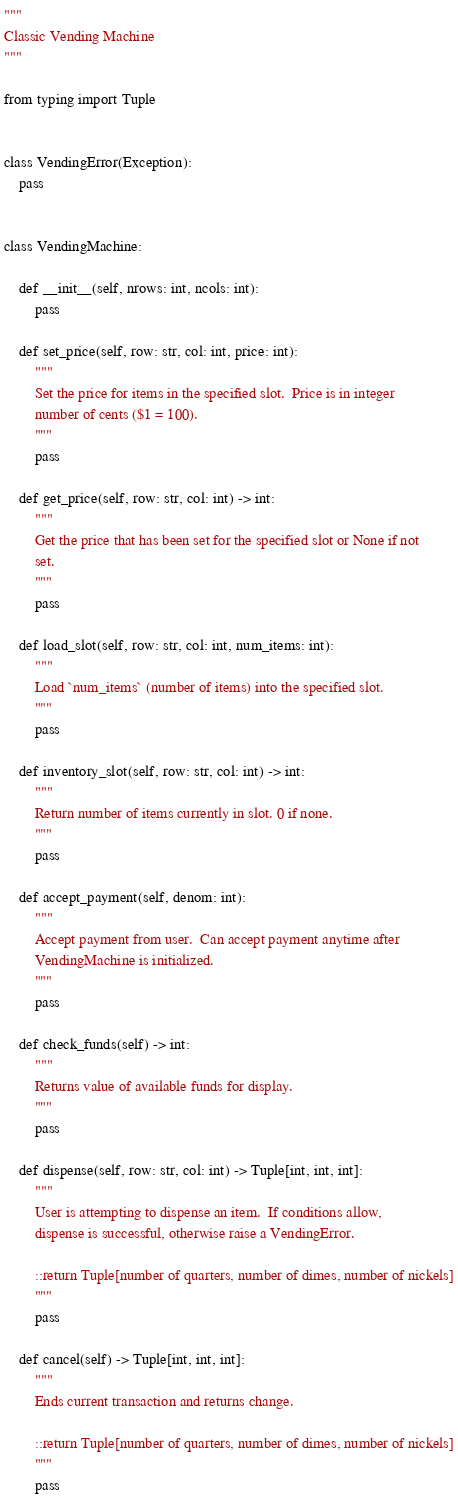Convert code to text. <code><loc_0><loc_0><loc_500><loc_500><_Python_>"""
Classic Vending Machine
"""

from typing import Tuple


class VendingError(Exception):
    pass


class VendingMachine:

    def __init__(self, nrows: int, ncols: int):
        pass

    def set_price(self, row: str, col: int, price: int):
        """
        Set the price for items in the specified slot.  Price is in integer
        number of cents ($1 = 100).
        """
        pass

    def get_price(self, row: str, col: int) -> int:
        """
        Get the price that has been set for the specified slot or None if not
        set.
        """
        pass

    def load_slot(self, row: str, col: int, num_items: int):
        """
        Load `num_items` (number of items) into the specified slot.
        """
        pass

    def inventory_slot(self, row: str, col: int) -> int:
        """
        Return number of items currently in slot. 0 if none.
        """
        pass

    def accept_payment(self, denom: int):
        """
        Accept payment from user.  Can accept payment anytime after
        VendingMachine is initialized.
        """
        pass

    def check_funds(self) -> int:
        """
        Returns value of available funds for display.
        """
        pass

    def dispense(self, row: str, col: int) -> Tuple[int, int, int]:
        """
        User is attempting to dispense an item.  If conditions allow,
        dispense is successful, otherwise raise a VendingError.

        ::return Tuple[number of quarters, number of dimes, number of nickels]
        """
        pass

    def cancel(self) -> Tuple[int, int, int]:
        """
        Ends current transaction and returns change.

        ::return Tuple[number of quarters, number of dimes, number of nickels]
        """
        pass
</code> 